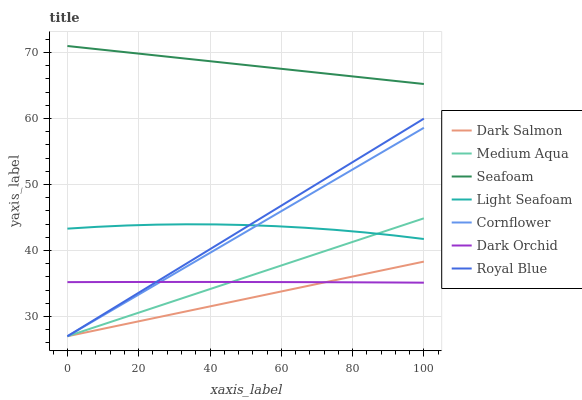Does Dark Salmon have the minimum area under the curve?
Answer yes or no. Yes. Does Seafoam have the maximum area under the curve?
Answer yes or no. Yes. Does Dark Orchid have the minimum area under the curve?
Answer yes or no. No. Does Dark Orchid have the maximum area under the curve?
Answer yes or no. No. Is Dark Salmon the smoothest?
Answer yes or no. Yes. Is Light Seafoam the roughest?
Answer yes or no. Yes. Is Dark Orchid the smoothest?
Answer yes or no. No. Is Dark Orchid the roughest?
Answer yes or no. No. Does Cornflower have the lowest value?
Answer yes or no. Yes. Does Dark Orchid have the lowest value?
Answer yes or no. No. Does Seafoam have the highest value?
Answer yes or no. Yes. Does Dark Salmon have the highest value?
Answer yes or no. No. Is Dark Orchid less than Light Seafoam?
Answer yes or no. Yes. Is Light Seafoam greater than Dark Orchid?
Answer yes or no. Yes. Does Dark Orchid intersect Medium Aqua?
Answer yes or no. Yes. Is Dark Orchid less than Medium Aqua?
Answer yes or no. No. Is Dark Orchid greater than Medium Aqua?
Answer yes or no. No. Does Dark Orchid intersect Light Seafoam?
Answer yes or no. No. 